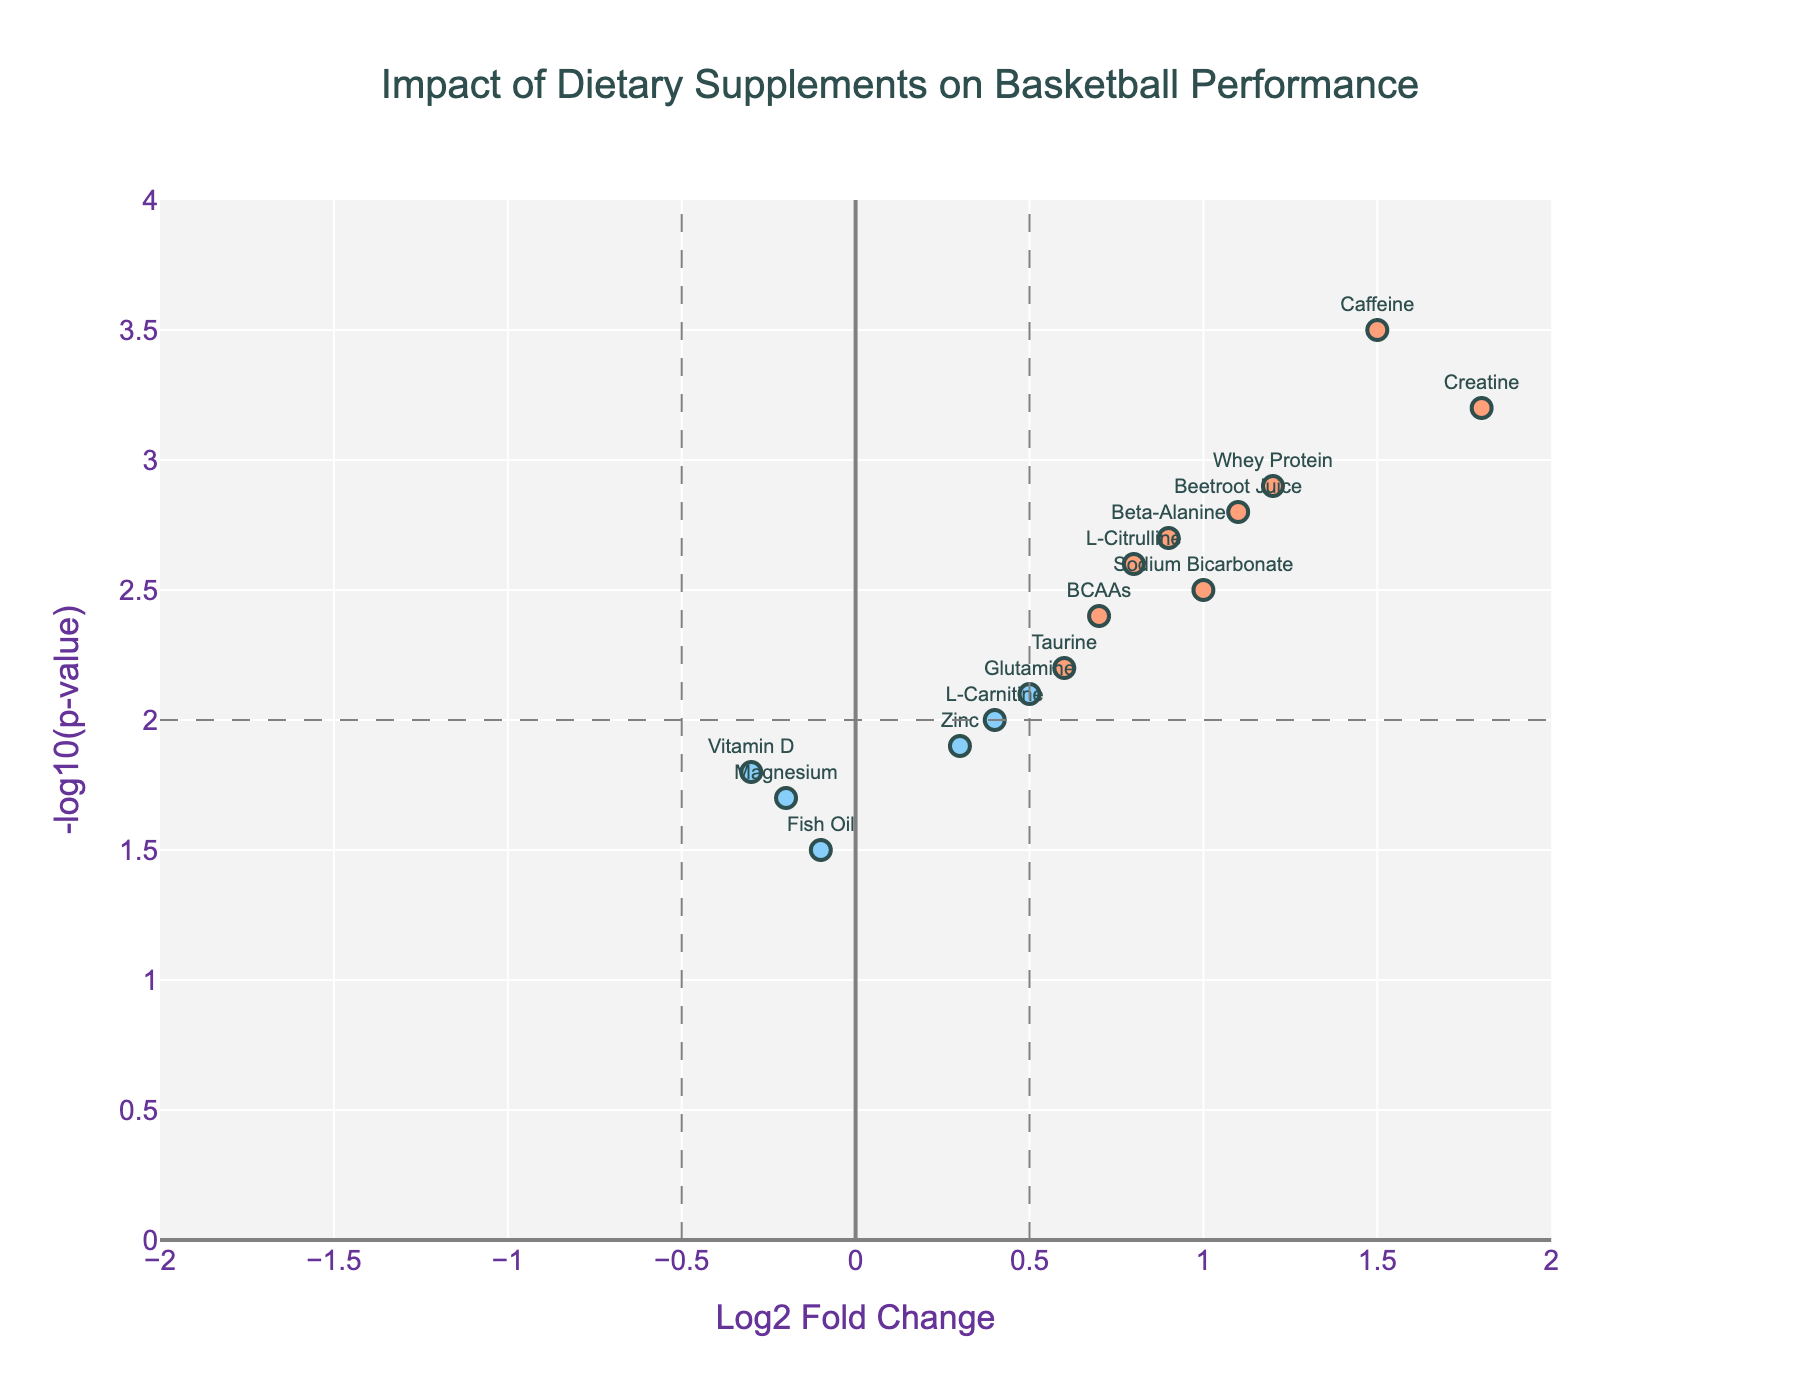What's the title of the plot? The title is usually located at the top of the plot and is meant to provide a summary of what the plot represents. Here, it describes the focus on dietary supplements and performance.
Answer: "Impact of Dietary Supplements on Basketball Performance" How many supplements show a significant positive impact on performance markers? To identify supplements with a significant positive impact, we look at those with both Log2 Fold Change greater than 0.5 and -log10(p-value) greater than 2.
Answer: 5 Which supplement has the highest Log2 Fold Change? We need to compare the Log2 Fold Change values of all supplements and find the maximum value. Creatine has the highest Log2 Fold Change at 1.8.
Answer: Creatine Are there any supplements with a negative Log2 Fold Change that are statistically significant? For a supplement to have a negative Log2 Fold Change and be statistically significant, Log2 Fold Change should be less than -0.5, and -log10(p-value) should be greater than 2. None of the supplements meet this criterion.
Answer: No What supplement has the highest -log10(p-value)? To find this, we compare the -log10(p-value) values and identify the maximum. Caffeine has the highest -log10(p-value) at 3.5.
Answer: Caffeine Which supplements have Log2 Fold Changes close to 1.0? We check the Log2 Fold Change values and find those around 1.0. Sodium Bicarbonate (1.0) and Beetroot Juice (1.1) are close to 1.0.
Answer: Sodium Bicarbonate and Beetroot Juice How many total data points are plotted on the volcano plot? Each supplement corresponds to one data point on the plot. Counting the list of supplements gives the total number of data points.
Answer: 14 What are the color criteria used for the data points? Data points are colored based on their Log2 Fold Change and -log10(p-value) values: significant positive impacts, only fold change significant, and others.
Answer: Based on significance criteria Among the supplements, which one has the smallest -log10(p-value)? We need to look for the minimum value in the -log10(p-value) column. Fish Oil has the smallest -log10(p-value) at 1.5.
Answer: Fish Oil 